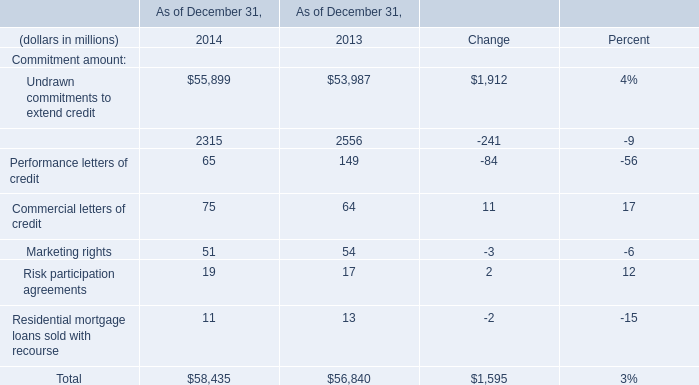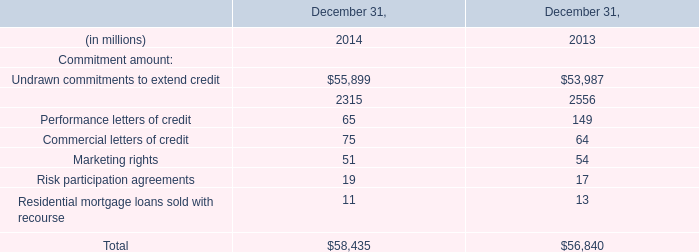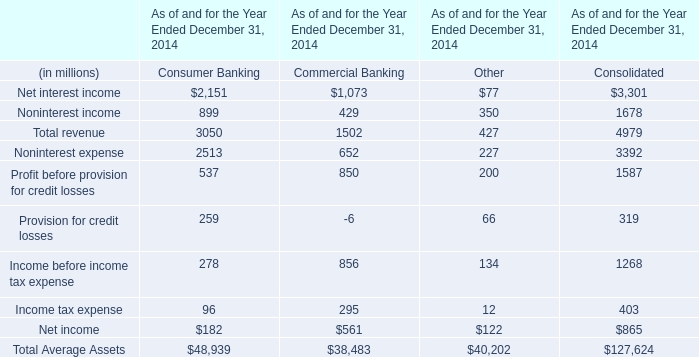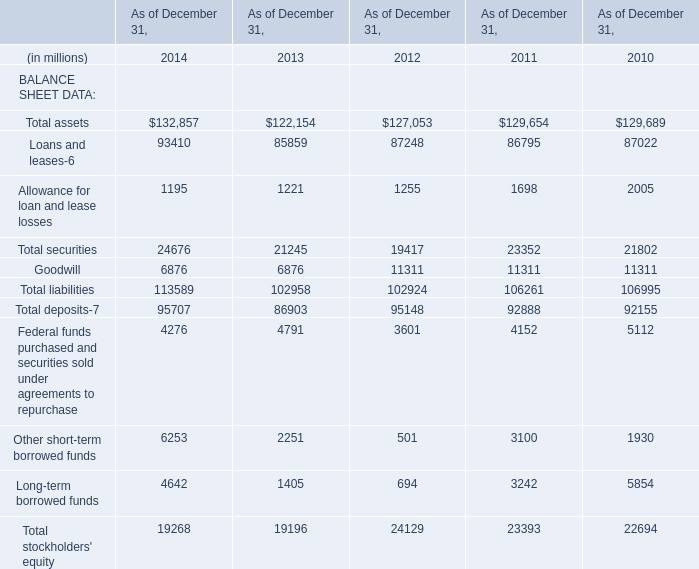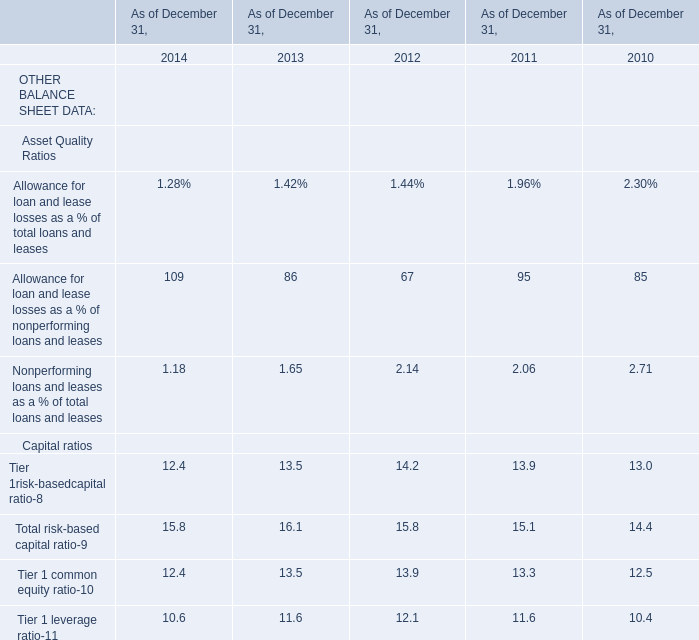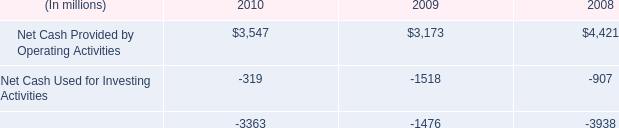What will Total liabilities reach in 2015 if it continues to grow at its current rate? (in million) 
Computations: (113589 * (1 + ((113589 - 102958) / 102958)))
Answer: 125317.71131. 